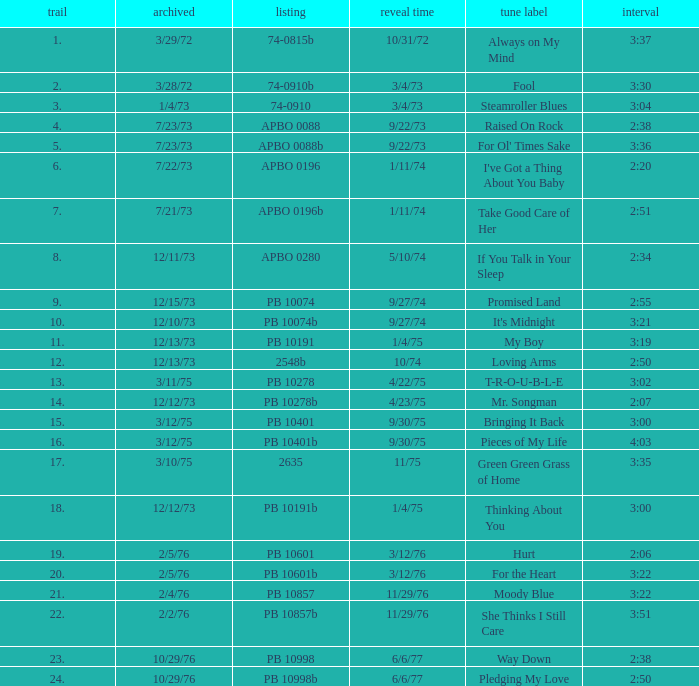I want the sum of tracks for raised on rock 4.0. 